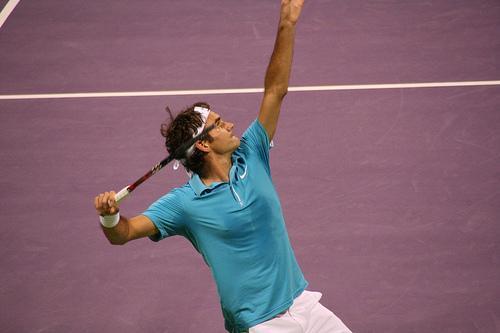How many blue shirts are in the photo?
Give a very brief answer. 1. 